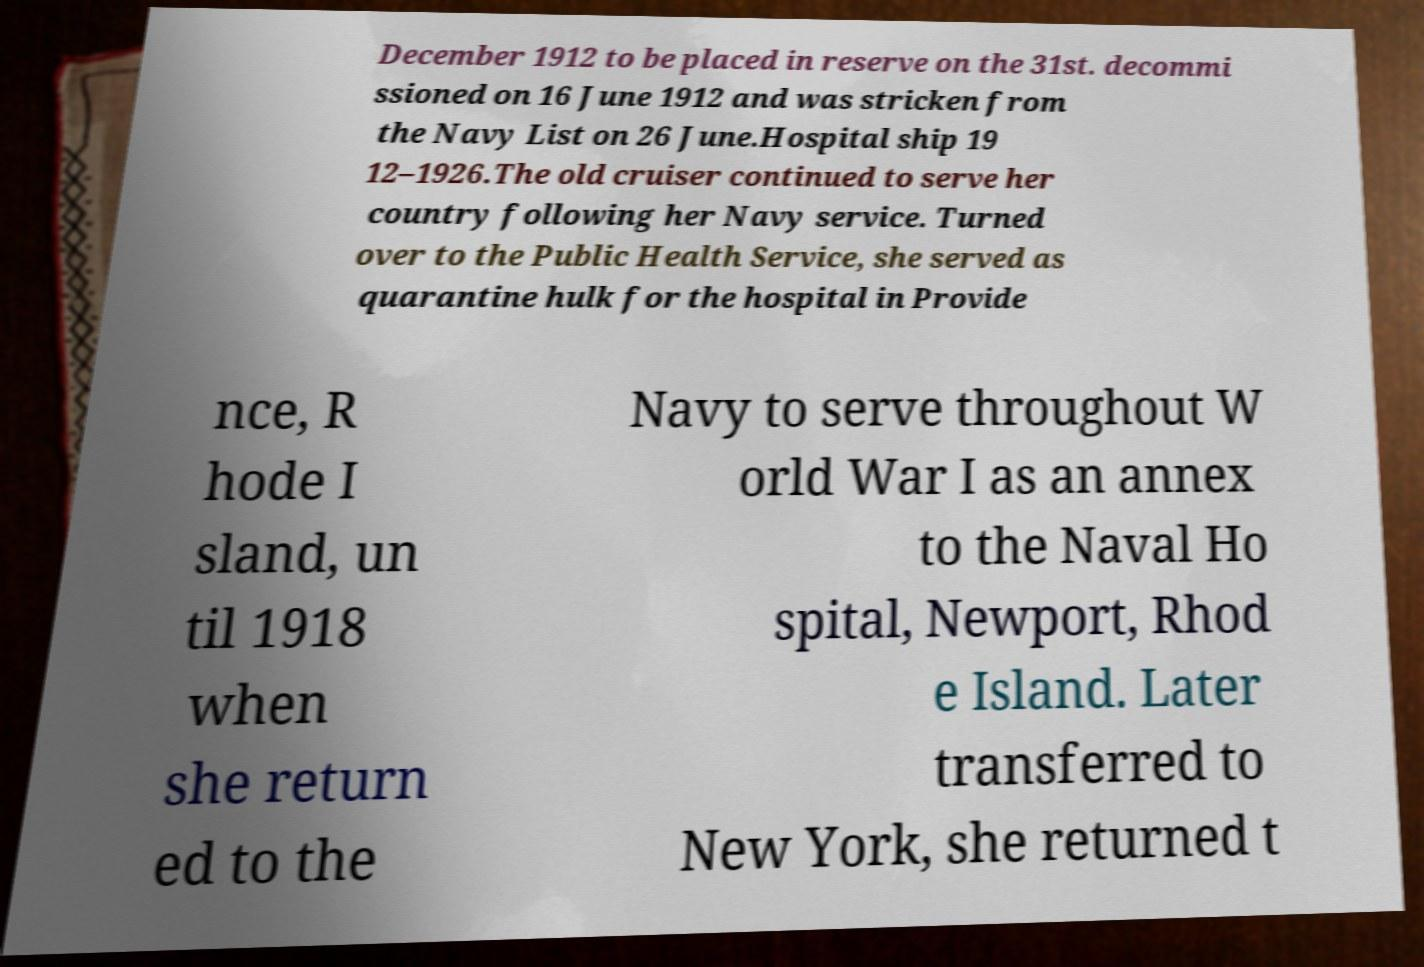Can you accurately transcribe the text from the provided image for me? December 1912 to be placed in reserve on the 31st. decommi ssioned on 16 June 1912 and was stricken from the Navy List on 26 June.Hospital ship 19 12–1926.The old cruiser continued to serve her country following her Navy service. Turned over to the Public Health Service, she served as quarantine hulk for the hospital in Provide nce, R hode I sland, un til 1918 when she return ed to the Navy to serve throughout W orld War I as an annex to the Naval Ho spital, Newport, Rhod e Island. Later transferred to New York, she returned t 